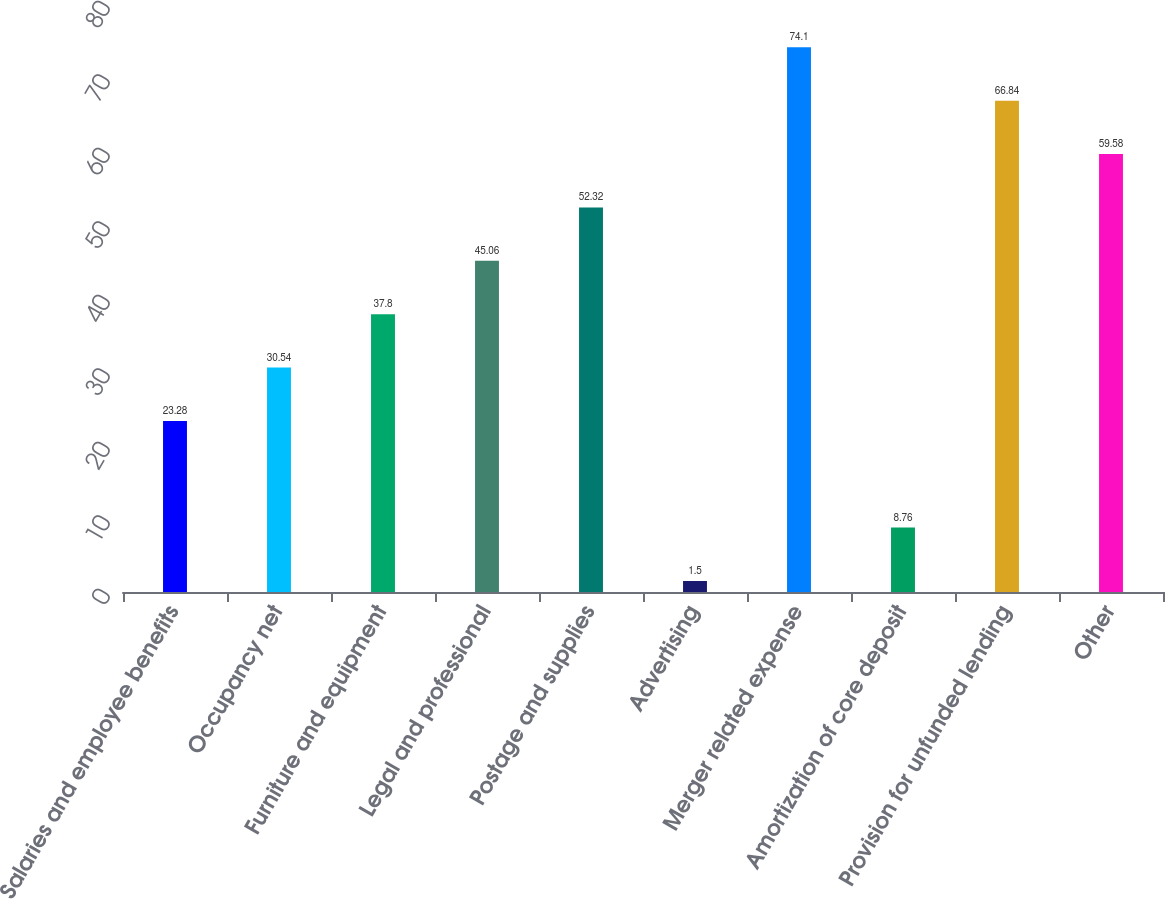Convert chart. <chart><loc_0><loc_0><loc_500><loc_500><bar_chart><fcel>Salaries and employee benefits<fcel>Occupancy net<fcel>Furniture and equipment<fcel>Legal and professional<fcel>Postage and supplies<fcel>Advertising<fcel>Merger related expense<fcel>Amortization of core deposit<fcel>Provision for unfunded lending<fcel>Other<nl><fcel>23.28<fcel>30.54<fcel>37.8<fcel>45.06<fcel>52.32<fcel>1.5<fcel>74.1<fcel>8.76<fcel>66.84<fcel>59.58<nl></chart> 